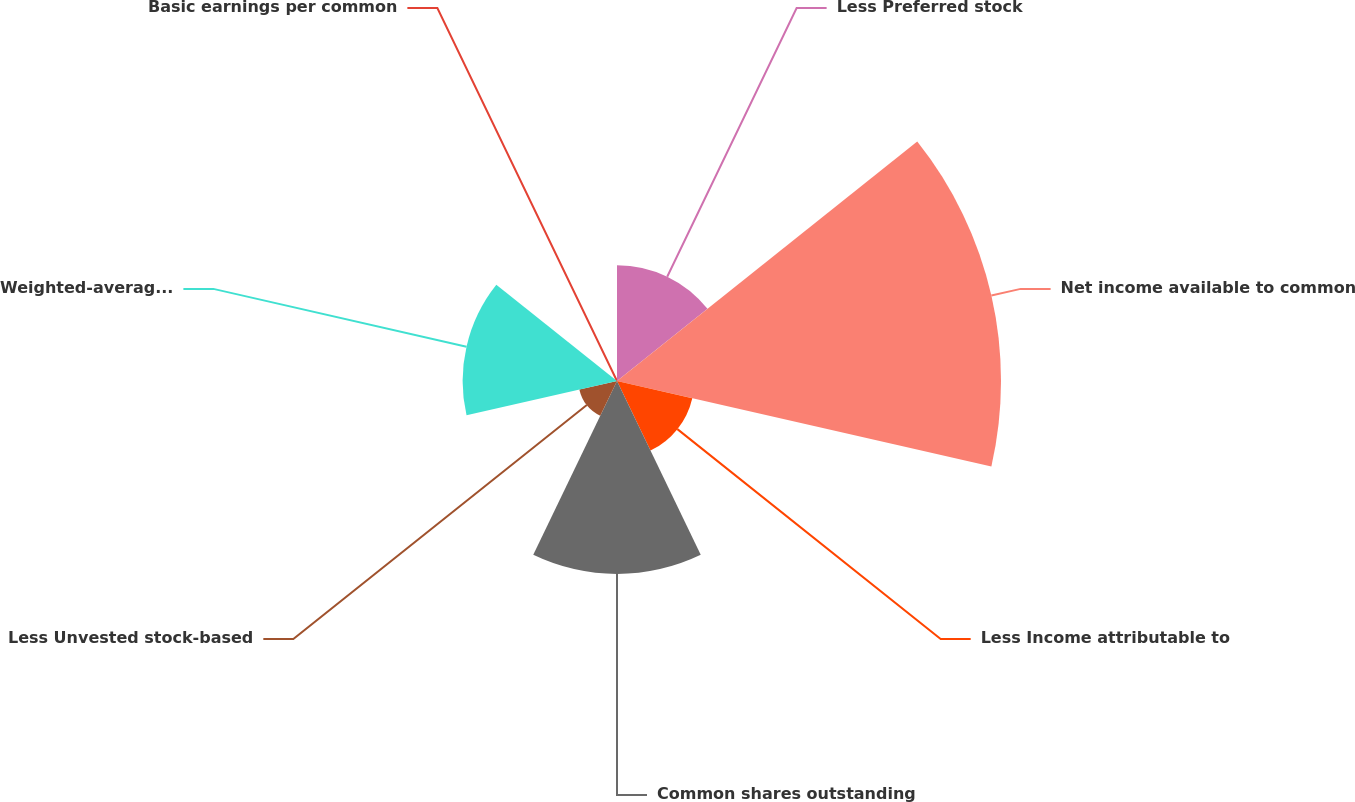Convert chart to OTSL. <chart><loc_0><loc_0><loc_500><loc_500><pie_chart><fcel>Less Preferred stock<fcel>Net income available to common<fcel>Less Income attributable to<fcel>Common shares outstanding<fcel>Less Unvested stock-based<fcel>Weighted-average shares<fcel>Basic earnings per common<nl><fcel>12.02%<fcel>39.88%<fcel>8.02%<fcel>20.04%<fcel>4.01%<fcel>16.03%<fcel>0.0%<nl></chart> 